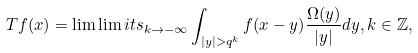Convert formula to latex. <formula><loc_0><loc_0><loc_500><loc_500>T f ( x ) = \lim \lim i t s _ { k \to - \infty } \int _ { | y | > q ^ { k } } f ( x - y ) \frac { \Omega ( y ) } { | y | } d y , k \in \mathbb { Z } ,</formula> 